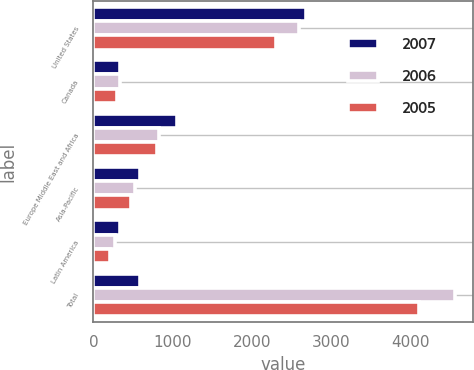Convert chart. <chart><loc_0><loc_0><loc_500><loc_500><stacked_bar_chart><ecel><fcel>United States<fcel>Canada<fcel>Europe Middle East and Africa<fcel>Asia-Pacific<fcel>Latin America<fcel>Total<nl><fcel>2007<fcel>2687<fcel>341.1<fcel>1054.2<fcel>588.8<fcel>332.8<fcel>588.8<nl><fcel>2006<fcel>2599<fcel>332.1<fcel>832.6<fcel>521.4<fcel>271.3<fcel>4556.4<nl><fcel>2005<fcel>2308.9<fcel>303.5<fcel>804<fcel>479.8<fcel>215.3<fcel>4111.5<nl></chart> 